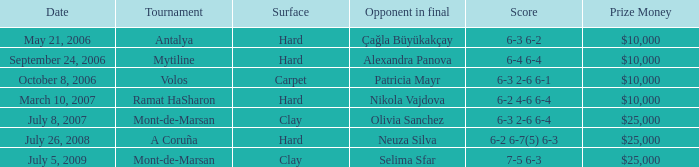What kind of surface is used for the volos tournament? Carpet. 